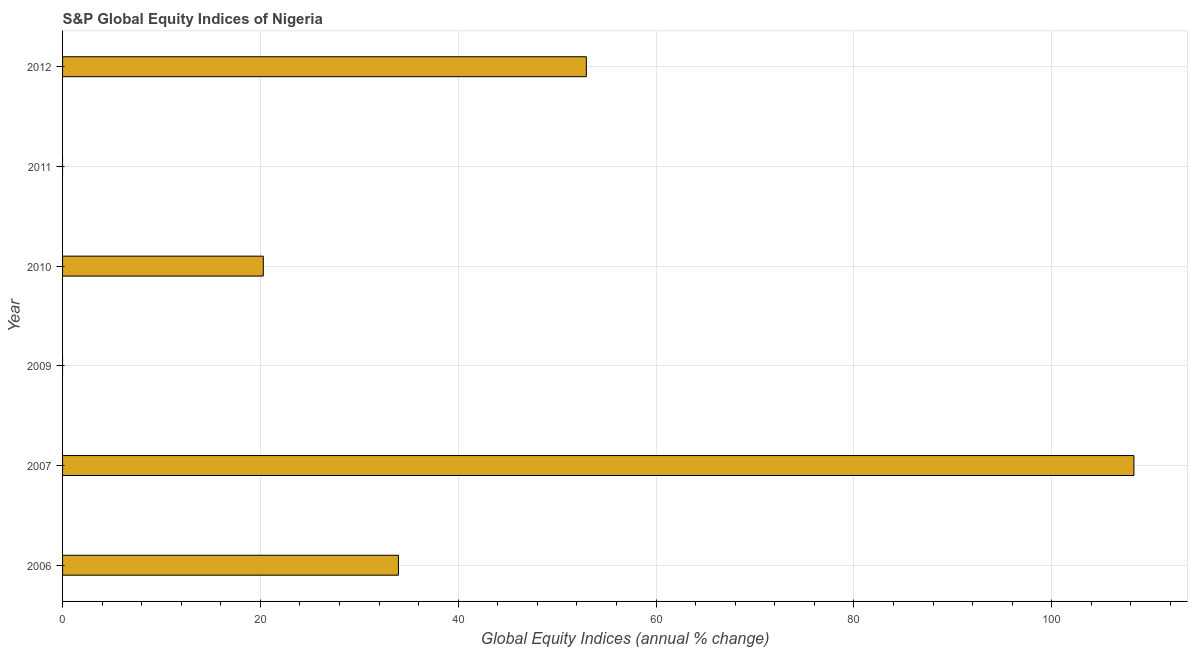Does the graph contain grids?
Provide a succinct answer. Yes. What is the title of the graph?
Your answer should be very brief. S&P Global Equity Indices of Nigeria. What is the label or title of the X-axis?
Offer a very short reply. Global Equity Indices (annual % change). Across all years, what is the maximum s&p global equity indices?
Ensure brevity in your answer.  108.3. Across all years, what is the minimum s&p global equity indices?
Provide a short and direct response. 0. In which year was the s&p global equity indices maximum?
Provide a short and direct response. 2007. What is the sum of the s&p global equity indices?
Offer a terse response. 215.5. What is the difference between the s&p global equity indices in 2007 and 2012?
Give a very brief answer. 55.35. What is the average s&p global equity indices per year?
Your response must be concise. 35.92. What is the median s&p global equity indices?
Your response must be concise. 27.12. What is the ratio of the s&p global equity indices in 2006 to that in 2010?
Offer a very short reply. 1.67. Is the s&p global equity indices in 2010 less than that in 2012?
Provide a short and direct response. Yes. What is the difference between the highest and the second highest s&p global equity indices?
Provide a short and direct response. 55.35. What is the difference between the highest and the lowest s&p global equity indices?
Keep it short and to the point. 108.3. Are the values on the major ticks of X-axis written in scientific E-notation?
Give a very brief answer. No. What is the Global Equity Indices (annual % change) of 2006?
Make the answer very short. 33.95. What is the Global Equity Indices (annual % change) in 2007?
Provide a short and direct response. 108.3. What is the Global Equity Indices (annual % change) of 2010?
Provide a short and direct response. 20.29. What is the Global Equity Indices (annual % change) in 2012?
Give a very brief answer. 52.95. What is the difference between the Global Equity Indices (annual % change) in 2006 and 2007?
Ensure brevity in your answer.  -74.35. What is the difference between the Global Equity Indices (annual % change) in 2006 and 2010?
Keep it short and to the point. 13.66. What is the difference between the Global Equity Indices (annual % change) in 2006 and 2012?
Provide a succinct answer. -19. What is the difference between the Global Equity Indices (annual % change) in 2007 and 2010?
Provide a succinct answer. 88.01. What is the difference between the Global Equity Indices (annual % change) in 2007 and 2012?
Keep it short and to the point. 55.35. What is the difference between the Global Equity Indices (annual % change) in 2010 and 2012?
Make the answer very short. -32.66. What is the ratio of the Global Equity Indices (annual % change) in 2006 to that in 2007?
Offer a terse response. 0.31. What is the ratio of the Global Equity Indices (annual % change) in 2006 to that in 2010?
Your response must be concise. 1.67. What is the ratio of the Global Equity Indices (annual % change) in 2006 to that in 2012?
Offer a very short reply. 0.64. What is the ratio of the Global Equity Indices (annual % change) in 2007 to that in 2010?
Your answer should be very brief. 5.34. What is the ratio of the Global Equity Indices (annual % change) in 2007 to that in 2012?
Offer a very short reply. 2.04. What is the ratio of the Global Equity Indices (annual % change) in 2010 to that in 2012?
Your response must be concise. 0.38. 